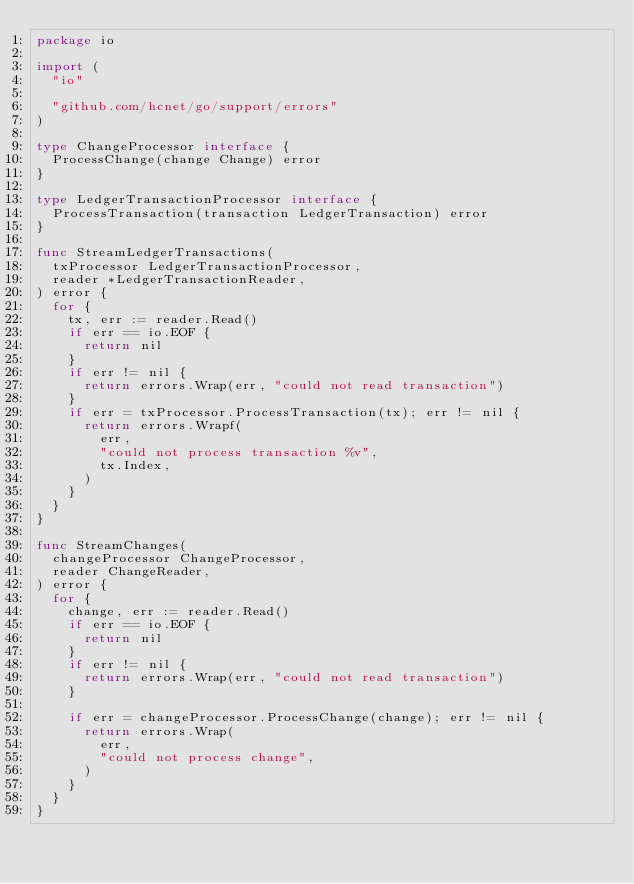<code> <loc_0><loc_0><loc_500><loc_500><_Go_>package io

import (
	"io"

	"github.com/hcnet/go/support/errors"
)

type ChangeProcessor interface {
	ProcessChange(change Change) error
}

type LedgerTransactionProcessor interface {
	ProcessTransaction(transaction LedgerTransaction) error
}

func StreamLedgerTransactions(
	txProcessor LedgerTransactionProcessor,
	reader *LedgerTransactionReader,
) error {
	for {
		tx, err := reader.Read()
		if err == io.EOF {
			return nil
		}
		if err != nil {
			return errors.Wrap(err, "could not read transaction")
		}
		if err = txProcessor.ProcessTransaction(tx); err != nil {
			return errors.Wrapf(
				err,
				"could not process transaction %v",
				tx.Index,
			)
		}
	}
}

func StreamChanges(
	changeProcessor ChangeProcessor,
	reader ChangeReader,
) error {
	for {
		change, err := reader.Read()
		if err == io.EOF {
			return nil
		}
		if err != nil {
			return errors.Wrap(err, "could not read transaction")
		}

		if err = changeProcessor.ProcessChange(change); err != nil {
			return errors.Wrap(
				err,
				"could not process change",
			)
		}
	}
}
</code> 